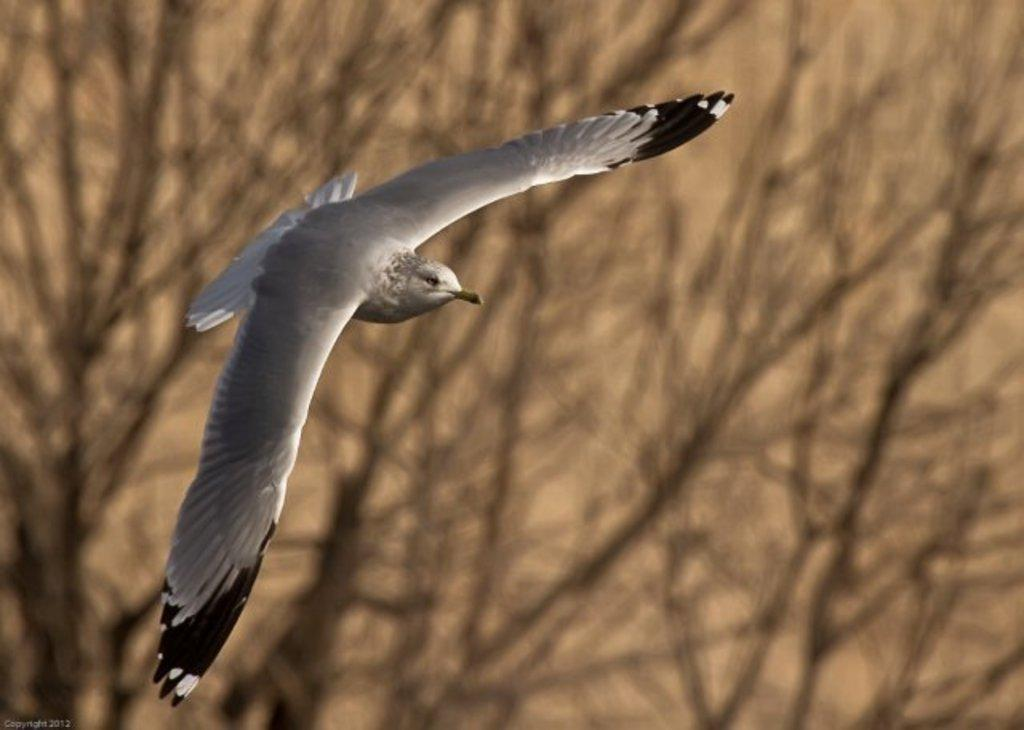What type of animal is in the image? There is a bird in the image. What is the bird doing in the image? The bird is flying. What colors can be seen on the bird? The bird has grey and black colors. What can be seen in the background of the image? There are trees in the background of the image. Where is the text located in the image? The text is at the bottom left of the image. How does the bird show respect to the deer in the image? There is no deer present in the image, so the bird cannot show respect to a deer. 